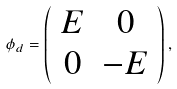Convert formula to latex. <formula><loc_0><loc_0><loc_500><loc_500>\phi _ { d } = \left ( \begin{array} { c c } E & 0 \\ 0 & - E \end{array} \right ) ,</formula> 